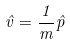<formula> <loc_0><loc_0><loc_500><loc_500>\hat { v } = \frac { 1 } { m } \hat { p }</formula> 